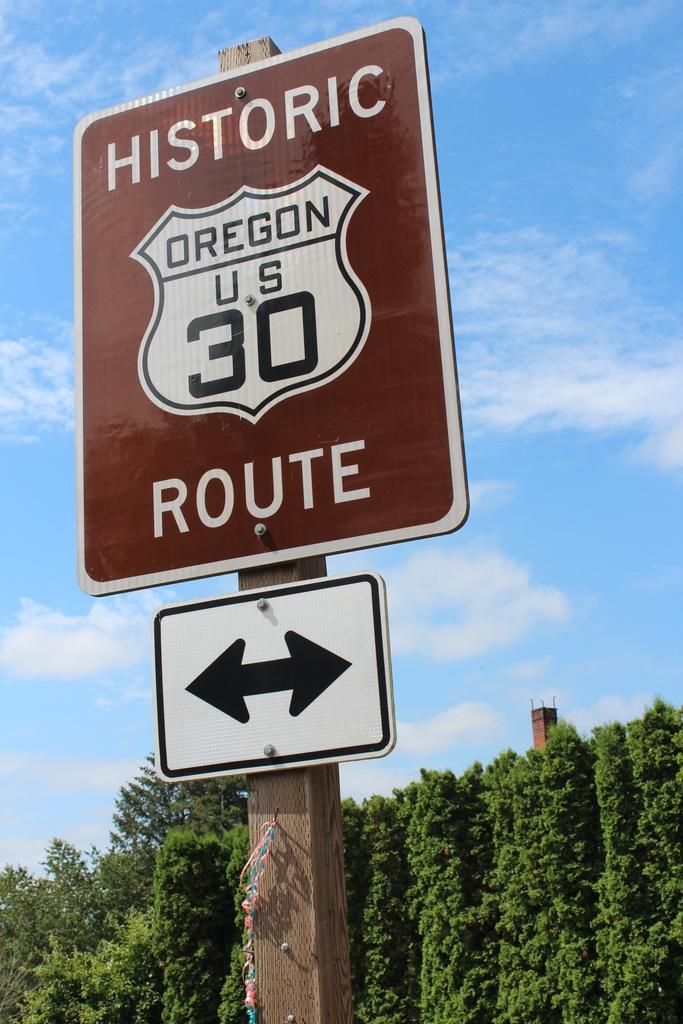What is the route number on the sign?
Provide a succinct answer. 30. What state is this sign in?
Your answer should be compact. Oregon. 